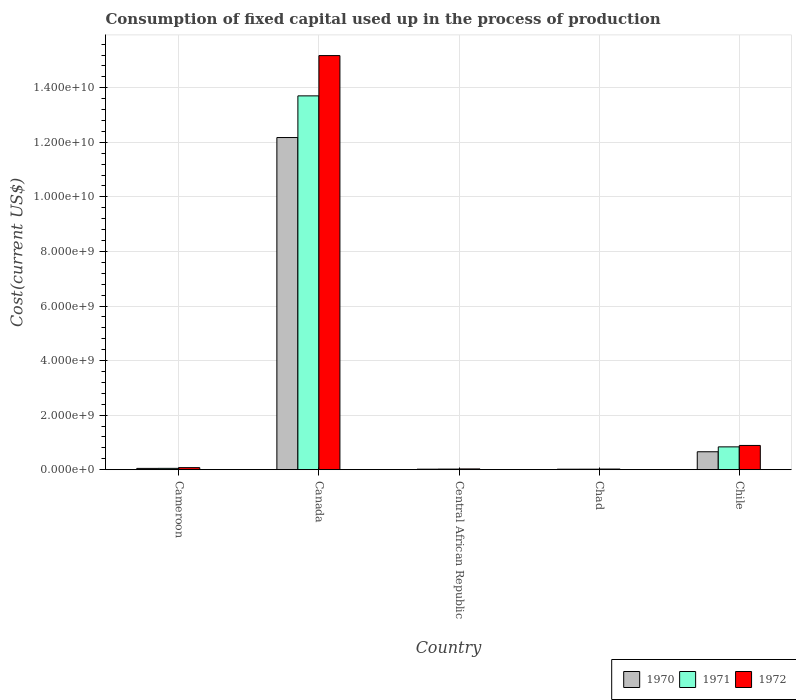How many groups of bars are there?
Offer a terse response. 5. In how many cases, is the number of bars for a given country not equal to the number of legend labels?
Keep it short and to the point. 0. What is the amount consumed in the process of production in 1972 in Central African Republic?
Your answer should be very brief. 2.81e+07. Across all countries, what is the maximum amount consumed in the process of production in 1972?
Your answer should be compact. 1.52e+1. Across all countries, what is the minimum amount consumed in the process of production in 1971?
Offer a very short reply. 1.92e+07. In which country was the amount consumed in the process of production in 1970 minimum?
Give a very brief answer. Chad. What is the total amount consumed in the process of production in 1972 in the graph?
Your response must be concise. 1.62e+1. What is the difference between the amount consumed in the process of production in 1971 in Canada and that in Chile?
Offer a terse response. 1.29e+1. What is the difference between the amount consumed in the process of production in 1972 in Canada and the amount consumed in the process of production in 1971 in Chad?
Your answer should be very brief. 1.52e+1. What is the average amount consumed in the process of production in 1971 per country?
Offer a very short reply. 2.93e+09. What is the difference between the amount consumed in the process of production of/in 1972 and amount consumed in the process of production of/in 1971 in Canada?
Your answer should be very brief. 1.48e+09. What is the ratio of the amount consumed in the process of production in 1971 in Canada to that in Central African Republic?
Ensure brevity in your answer.  609.14. Is the difference between the amount consumed in the process of production in 1972 in Cameroon and Chad greater than the difference between the amount consumed in the process of production in 1971 in Cameroon and Chad?
Offer a terse response. Yes. What is the difference between the highest and the second highest amount consumed in the process of production in 1970?
Offer a very short reply. 1.15e+1. What is the difference between the highest and the lowest amount consumed in the process of production in 1970?
Your answer should be very brief. 1.22e+1. In how many countries, is the amount consumed in the process of production in 1971 greater than the average amount consumed in the process of production in 1971 taken over all countries?
Offer a very short reply. 1. Is the sum of the amount consumed in the process of production in 1972 in Central African Republic and Chile greater than the maximum amount consumed in the process of production in 1970 across all countries?
Make the answer very short. No. What does the 1st bar from the right in Chile represents?
Ensure brevity in your answer.  1972. Is it the case that in every country, the sum of the amount consumed in the process of production in 1972 and amount consumed in the process of production in 1971 is greater than the amount consumed in the process of production in 1970?
Keep it short and to the point. Yes. How many bars are there?
Your answer should be compact. 15. Are all the bars in the graph horizontal?
Your answer should be very brief. No. What is the difference between two consecutive major ticks on the Y-axis?
Keep it short and to the point. 2.00e+09. Are the values on the major ticks of Y-axis written in scientific E-notation?
Give a very brief answer. Yes. How are the legend labels stacked?
Your answer should be compact. Horizontal. What is the title of the graph?
Provide a short and direct response. Consumption of fixed capital used up in the process of production. What is the label or title of the X-axis?
Provide a succinct answer. Country. What is the label or title of the Y-axis?
Keep it short and to the point. Cost(current US$). What is the Cost(current US$) in 1970 in Cameroon?
Make the answer very short. 4.77e+07. What is the Cost(current US$) of 1971 in Cameroon?
Give a very brief answer. 4.96e+07. What is the Cost(current US$) of 1972 in Cameroon?
Provide a short and direct response. 7.55e+07. What is the Cost(current US$) in 1970 in Canada?
Your response must be concise. 1.22e+1. What is the Cost(current US$) in 1971 in Canada?
Ensure brevity in your answer.  1.37e+1. What is the Cost(current US$) in 1972 in Canada?
Your response must be concise. 1.52e+1. What is the Cost(current US$) in 1970 in Central African Republic?
Ensure brevity in your answer.  1.88e+07. What is the Cost(current US$) in 1971 in Central African Republic?
Keep it short and to the point. 2.25e+07. What is the Cost(current US$) of 1972 in Central African Republic?
Make the answer very short. 2.81e+07. What is the Cost(current US$) of 1970 in Chad?
Provide a short and direct response. 1.87e+07. What is the Cost(current US$) of 1971 in Chad?
Provide a short and direct response. 1.92e+07. What is the Cost(current US$) in 1972 in Chad?
Your answer should be compact. 2.37e+07. What is the Cost(current US$) in 1970 in Chile?
Keep it short and to the point. 6.58e+08. What is the Cost(current US$) in 1971 in Chile?
Offer a very short reply. 8.37e+08. What is the Cost(current US$) of 1972 in Chile?
Keep it short and to the point. 8.89e+08. Across all countries, what is the maximum Cost(current US$) of 1970?
Provide a short and direct response. 1.22e+1. Across all countries, what is the maximum Cost(current US$) of 1971?
Make the answer very short. 1.37e+1. Across all countries, what is the maximum Cost(current US$) of 1972?
Your response must be concise. 1.52e+1. Across all countries, what is the minimum Cost(current US$) of 1970?
Give a very brief answer. 1.87e+07. Across all countries, what is the minimum Cost(current US$) in 1971?
Ensure brevity in your answer.  1.92e+07. Across all countries, what is the minimum Cost(current US$) of 1972?
Your response must be concise. 2.37e+07. What is the total Cost(current US$) of 1970 in the graph?
Provide a short and direct response. 1.29e+1. What is the total Cost(current US$) of 1971 in the graph?
Ensure brevity in your answer.  1.46e+1. What is the total Cost(current US$) in 1972 in the graph?
Your answer should be compact. 1.62e+1. What is the difference between the Cost(current US$) of 1970 in Cameroon and that in Canada?
Your response must be concise. -1.21e+1. What is the difference between the Cost(current US$) in 1971 in Cameroon and that in Canada?
Make the answer very short. -1.37e+1. What is the difference between the Cost(current US$) in 1972 in Cameroon and that in Canada?
Keep it short and to the point. -1.51e+1. What is the difference between the Cost(current US$) in 1970 in Cameroon and that in Central African Republic?
Keep it short and to the point. 2.89e+07. What is the difference between the Cost(current US$) in 1971 in Cameroon and that in Central African Republic?
Offer a very short reply. 2.71e+07. What is the difference between the Cost(current US$) in 1972 in Cameroon and that in Central African Republic?
Ensure brevity in your answer.  4.75e+07. What is the difference between the Cost(current US$) of 1970 in Cameroon and that in Chad?
Give a very brief answer. 2.90e+07. What is the difference between the Cost(current US$) in 1971 in Cameroon and that in Chad?
Offer a very short reply. 3.04e+07. What is the difference between the Cost(current US$) in 1972 in Cameroon and that in Chad?
Give a very brief answer. 5.19e+07. What is the difference between the Cost(current US$) of 1970 in Cameroon and that in Chile?
Give a very brief answer. -6.10e+08. What is the difference between the Cost(current US$) of 1971 in Cameroon and that in Chile?
Provide a succinct answer. -7.87e+08. What is the difference between the Cost(current US$) of 1972 in Cameroon and that in Chile?
Your answer should be very brief. -8.13e+08. What is the difference between the Cost(current US$) of 1970 in Canada and that in Central African Republic?
Your answer should be compact. 1.22e+1. What is the difference between the Cost(current US$) of 1971 in Canada and that in Central African Republic?
Provide a succinct answer. 1.37e+1. What is the difference between the Cost(current US$) of 1972 in Canada and that in Central African Republic?
Keep it short and to the point. 1.52e+1. What is the difference between the Cost(current US$) in 1970 in Canada and that in Chad?
Your answer should be very brief. 1.22e+1. What is the difference between the Cost(current US$) of 1971 in Canada and that in Chad?
Offer a terse response. 1.37e+1. What is the difference between the Cost(current US$) of 1972 in Canada and that in Chad?
Provide a succinct answer. 1.52e+1. What is the difference between the Cost(current US$) of 1970 in Canada and that in Chile?
Offer a very short reply. 1.15e+1. What is the difference between the Cost(current US$) in 1971 in Canada and that in Chile?
Your response must be concise. 1.29e+1. What is the difference between the Cost(current US$) of 1972 in Canada and that in Chile?
Provide a short and direct response. 1.43e+1. What is the difference between the Cost(current US$) in 1970 in Central African Republic and that in Chad?
Ensure brevity in your answer.  1.44e+05. What is the difference between the Cost(current US$) of 1971 in Central African Republic and that in Chad?
Make the answer very short. 3.32e+06. What is the difference between the Cost(current US$) in 1972 in Central African Republic and that in Chad?
Give a very brief answer. 4.39e+06. What is the difference between the Cost(current US$) in 1970 in Central African Republic and that in Chile?
Offer a very short reply. -6.39e+08. What is the difference between the Cost(current US$) in 1971 in Central African Republic and that in Chile?
Your answer should be very brief. -8.14e+08. What is the difference between the Cost(current US$) of 1972 in Central African Republic and that in Chile?
Keep it short and to the point. -8.61e+08. What is the difference between the Cost(current US$) of 1970 in Chad and that in Chile?
Provide a succinct answer. -6.39e+08. What is the difference between the Cost(current US$) in 1971 in Chad and that in Chile?
Give a very brief answer. -8.17e+08. What is the difference between the Cost(current US$) in 1972 in Chad and that in Chile?
Offer a terse response. -8.65e+08. What is the difference between the Cost(current US$) of 1970 in Cameroon and the Cost(current US$) of 1971 in Canada?
Your answer should be very brief. -1.37e+1. What is the difference between the Cost(current US$) in 1970 in Cameroon and the Cost(current US$) in 1972 in Canada?
Offer a terse response. -1.51e+1. What is the difference between the Cost(current US$) in 1971 in Cameroon and the Cost(current US$) in 1972 in Canada?
Provide a succinct answer. -1.51e+1. What is the difference between the Cost(current US$) in 1970 in Cameroon and the Cost(current US$) in 1971 in Central African Republic?
Offer a very short reply. 2.52e+07. What is the difference between the Cost(current US$) of 1970 in Cameroon and the Cost(current US$) of 1972 in Central African Republic?
Provide a succinct answer. 1.96e+07. What is the difference between the Cost(current US$) in 1971 in Cameroon and the Cost(current US$) in 1972 in Central African Republic?
Give a very brief answer. 2.15e+07. What is the difference between the Cost(current US$) in 1970 in Cameroon and the Cost(current US$) in 1971 in Chad?
Offer a very short reply. 2.85e+07. What is the difference between the Cost(current US$) in 1970 in Cameroon and the Cost(current US$) in 1972 in Chad?
Provide a succinct answer. 2.40e+07. What is the difference between the Cost(current US$) of 1971 in Cameroon and the Cost(current US$) of 1972 in Chad?
Your response must be concise. 2.59e+07. What is the difference between the Cost(current US$) in 1970 in Cameroon and the Cost(current US$) in 1971 in Chile?
Offer a terse response. -7.89e+08. What is the difference between the Cost(current US$) in 1970 in Cameroon and the Cost(current US$) in 1972 in Chile?
Your answer should be very brief. -8.41e+08. What is the difference between the Cost(current US$) of 1971 in Cameroon and the Cost(current US$) of 1972 in Chile?
Your answer should be very brief. -8.39e+08. What is the difference between the Cost(current US$) in 1970 in Canada and the Cost(current US$) in 1971 in Central African Republic?
Make the answer very short. 1.22e+1. What is the difference between the Cost(current US$) in 1970 in Canada and the Cost(current US$) in 1972 in Central African Republic?
Keep it short and to the point. 1.21e+1. What is the difference between the Cost(current US$) of 1971 in Canada and the Cost(current US$) of 1972 in Central African Republic?
Provide a succinct answer. 1.37e+1. What is the difference between the Cost(current US$) in 1970 in Canada and the Cost(current US$) in 1971 in Chad?
Keep it short and to the point. 1.22e+1. What is the difference between the Cost(current US$) of 1970 in Canada and the Cost(current US$) of 1972 in Chad?
Make the answer very short. 1.22e+1. What is the difference between the Cost(current US$) in 1971 in Canada and the Cost(current US$) in 1972 in Chad?
Your answer should be compact. 1.37e+1. What is the difference between the Cost(current US$) in 1970 in Canada and the Cost(current US$) in 1971 in Chile?
Your answer should be very brief. 1.13e+1. What is the difference between the Cost(current US$) in 1970 in Canada and the Cost(current US$) in 1972 in Chile?
Keep it short and to the point. 1.13e+1. What is the difference between the Cost(current US$) of 1971 in Canada and the Cost(current US$) of 1972 in Chile?
Provide a short and direct response. 1.28e+1. What is the difference between the Cost(current US$) of 1970 in Central African Republic and the Cost(current US$) of 1971 in Chad?
Ensure brevity in your answer.  -3.35e+05. What is the difference between the Cost(current US$) of 1970 in Central African Republic and the Cost(current US$) of 1972 in Chad?
Your response must be concise. -4.84e+06. What is the difference between the Cost(current US$) of 1971 in Central African Republic and the Cost(current US$) of 1972 in Chad?
Ensure brevity in your answer.  -1.18e+06. What is the difference between the Cost(current US$) in 1970 in Central African Republic and the Cost(current US$) in 1971 in Chile?
Give a very brief answer. -8.18e+08. What is the difference between the Cost(current US$) in 1970 in Central African Republic and the Cost(current US$) in 1972 in Chile?
Your answer should be compact. -8.70e+08. What is the difference between the Cost(current US$) of 1971 in Central African Republic and the Cost(current US$) of 1972 in Chile?
Give a very brief answer. -8.66e+08. What is the difference between the Cost(current US$) of 1970 in Chad and the Cost(current US$) of 1971 in Chile?
Provide a succinct answer. -8.18e+08. What is the difference between the Cost(current US$) of 1970 in Chad and the Cost(current US$) of 1972 in Chile?
Keep it short and to the point. -8.70e+08. What is the difference between the Cost(current US$) in 1971 in Chad and the Cost(current US$) in 1972 in Chile?
Your answer should be very brief. -8.70e+08. What is the average Cost(current US$) in 1970 per country?
Keep it short and to the point. 2.58e+09. What is the average Cost(current US$) in 1971 per country?
Give a very brief answer. 2.93e+09. What is the average Cost(current US$) in 1972 per country?
Provide a succinct answer. 3.24e+09. What is the difference between the Cost(current US$) of 1970 and Cost(current US$) of 1971 in Cameroon?
Keep it short and to the point. -1.86e+06. What is the difference between the Cost(current US$) in 1970 and Cost(current US$) in 1972 in Cameroon?
Your answer should be compact. -2.78e+07. What is the difference between the Cost(current US$) in 1971 and Cost(current US$) in 1972 in Cameroon?
Keep it short and to the point. -2.60e+07. What is the difference between the Cost(current US$) in 1970 and Cost(current US$) in 1971 in Canada?
Your response must be concise. -1.53e+09. What is the difference between the Cost(current US$) of 1970 and Cost(current US$) of 1972 in Canada?
Make the answer very short. -3.00e+09. What is the difference between the Cost(current US$) of 1971 and Cost(current US$) of 1972 in Canada?
Offer a terse response. -1.48e+09. What is the difference between the Cost(current US$) in 1970 and Cost(current US$) in 1971 in Central African Republic?
Ensure brevity in your answer.  -3.66e+06. What is the difference between the Cost(current US$) in 1970 and Cost(current US$) in 1972 in Central African Republic?
Provide a short and direct response. -9.23e+06. What is the difference between the Cost(current US$) in 1971 and Cost(current US$) in 1972 in Central African Republic?
Keep it short and to the point. -5.57e+06. What is the difference between the Cost(current US$) of 1970 and Cost(current US$) of 1971 in Chad?
Offer a terse response. -4.79e+05. What is the difference between the Cost(current US$) in 1970 and Cost(current US$) in 1972 in Chad?
Keep it short and to the point. -4.98e+06. What is the difference between the Cost(current US$) in 1971 and Cost(current US$) in 1972 in Chad?
Offer a very short reply. -4.50e+06. What is the difference between the Cost(current US$) of 1970 and Cost(current US$) of 1971 in Chile?
Keep it short and to the point. -1.79e+08. What is the difference between the Cost(current US$) of 1970 and Cost(current US$) of 1972 in Chile?
Your response must be concise. -2.31e+08. What is the difference between the Cost(current US$) in 1971 and Cost(current US$) in 1972 in Chile?
Offer a terse response. -5.24e+07. What is the ratio of the Cost(current US$) in 1970 in Cameroon to that in Canada?
Provide a succinct answer. 0. What is the ratio of the Cost(current US$) in 1971 in Cameroon to that in Canada?
Make the answer very short. 0. What is the ratio of the Cost(current US$) in 1972 in Cameroon to that in Canada?
Provide a succinct answer. 0.01. What is the ratio of the Cost(current US$) of 1970 in Cameroon to that in Central African Republic?
Give a very brief answer. 2.53. What is the ratio of the Cost(current US$) in 1971 in Cameroon to that in Central African Republic?
Your answer should be compact. 2.2. What is the ratio of the Cost(current US$) of 1972 in Cameroon to that in Central African Republic?
Your answer should be compact. 2.69. What is the ratio of the Cost(current US$) of 1970 in Cameroon to that in Chad?
Offer a very short reply. 2.55. What is the ratio of the Cost(current US$) of 1971 in Cameroon to that in Chad?
Make the answer very short. 2.59. What is the ratio of the Cost(current US$) of 1972 in Cameroon to that in Chad?
Provide a succinct answer. 3.19. What is the ratio of the Cost(current US$) in 1970 in Cameroon to that in Chile?
Keep it short and to the point. 0.07. What is the ratio of the Cost(current US$) in 1971 in Cameroon to that in Chile?
Give a very brief answer. 0.06. What is the ratio of the Cost(current US$) of 1972 in Cameroon to that in Chile?
Make the answer very short. 0.09. What is the ratio of the Cost(current US$) of 1970 in Canada to that in Central African Republic?
Your answer should be very brief. 646.41. What is the ratio of the Cost(current US$) in 1971 in Canada to that in Central African Republic?
Make the answer very short. 609.14. What is the ratio of the Cost(current US$) of 1972 in Canada to that in Central African Republic?
Offer a terse response. 540.96. What is the ratio of the Cost(current US$) of 1970 in Canada to that in Chad?
Offer a terse response. 651.37. What is the ratio of the Cost(current US$) in 1971 in Canada to that in Chad?
Keep it short and to the point. 714.79. What is the ratio of the Cost(current US$) in 1972 in Canada to that in Chad?
Your response must be concise. 641.21. What is the ratio of the Cost(current US$) of 1970 in Canada to that in Chile?
Provide a succinct answer. 18.51. What is the ratio of the Cost(current US$) in 1971 in Canada to that in Chile?
Provide a succinct answer. 16.38. What is the ratio of the Cost(current US$) in 1972 in Canada to that in Chile?
Offer a very short reply. 17.08. What is the ratio of the Cost(current US$) of 1970 in Central African Republic to that in Chad?
Offer a very short reply. 1.01. What is the ratio of the Cost(current US$) of 1971 in Central African Republic to that in Chad?
Provide a short and direct response. 1.17. What is the ratio of the Cost(current US$) in 1972 in Central African Republic to that in Chad?
Make the answer very short. 1.19. What is the ratio of the Cost(current US$) in 1970 in Central African Republic to that in Chile?
Your answer should be very brief. 0.03. What is the ratio of the Cost(current US$) in 1971 in Central African Republic to that in Chile?
Give a very brief answer. 0.03. What is the ratio of the Cost(current US$) in 1972 in Central African Republic to that in Chile?
Your response must be concise. 0.03. What is the ratio of the Cost(current US$) in 1970 in Chad to that in Chile?
Your response must be concise. 0.03. What is the ratio of the Cost(current US$) of 1971 in Chad to that in Chile?
Give a very brief answer. 0.02. What is the ratio of the Cost(current US$) of 1972 in Chad to that in Chile?
Offer a very short reply. 0.03. What is the difference between the highest and the second highest Cost(current US$) in 1970?
Offer a very short reply. 1.15e+1. What is the difference between the highest and the second highest Cost(current US$) of 1971?
Give a very brief answer. 1.29e+1. What is the difference between the highest and the second highest Cost(current US$) of 1972?
Make the answer very short. 1.43e+1. What is the difference between the highest and the lowest Cost(current US$) in 1970?
Provide a succinct answer. 1.22e+1. What is the difference between the highest and the lowest Cost(current US$) in 1971?
Your answer should be compact. 1.37e+1. What is the difference between the highest and the lowest Cost(current US$) in 1972?
Give a very brief answer. 1.52e+1. 